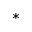<formula> <loc_0><loc_0><loc_500><loc_500>^ { * }</formula> 